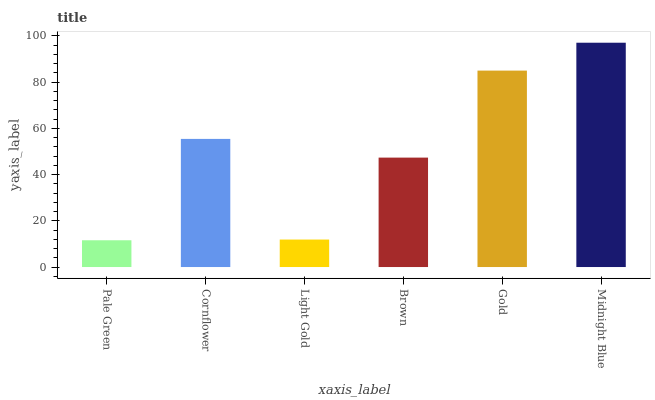Is Pale Green the minimum?
Answer yes or no. Yes. Is Midnight Blue the maximum?
Answer yes or no. Yes. Is Cornflower the minimum?
Answer yes or no. No. Is Cornflower the maximum?
Answer yes or no. No. Is Cornflower greater than Pale Green?
Answer yes or no. Yes. Is Pale Green less than Cornflower?
Answer yes or no. Yes. Is Pale Green greater than Cornflower?
Answer yes or no. No. Is Cornflower less than Pale Green?
Answer yes or no. No. Is Cornflower the high median?
Answer yes or no. Yes. Is Brown the low median?
Answer yes or no. Yes. Is Midnight Blue the high median?
Answer yes or no. No. Is Cornflower the low median?
Answer yes or no. No. 